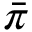<formula> <loc_0><loc_0><loc_500><loc_500>\bar { \pi }</formula> 